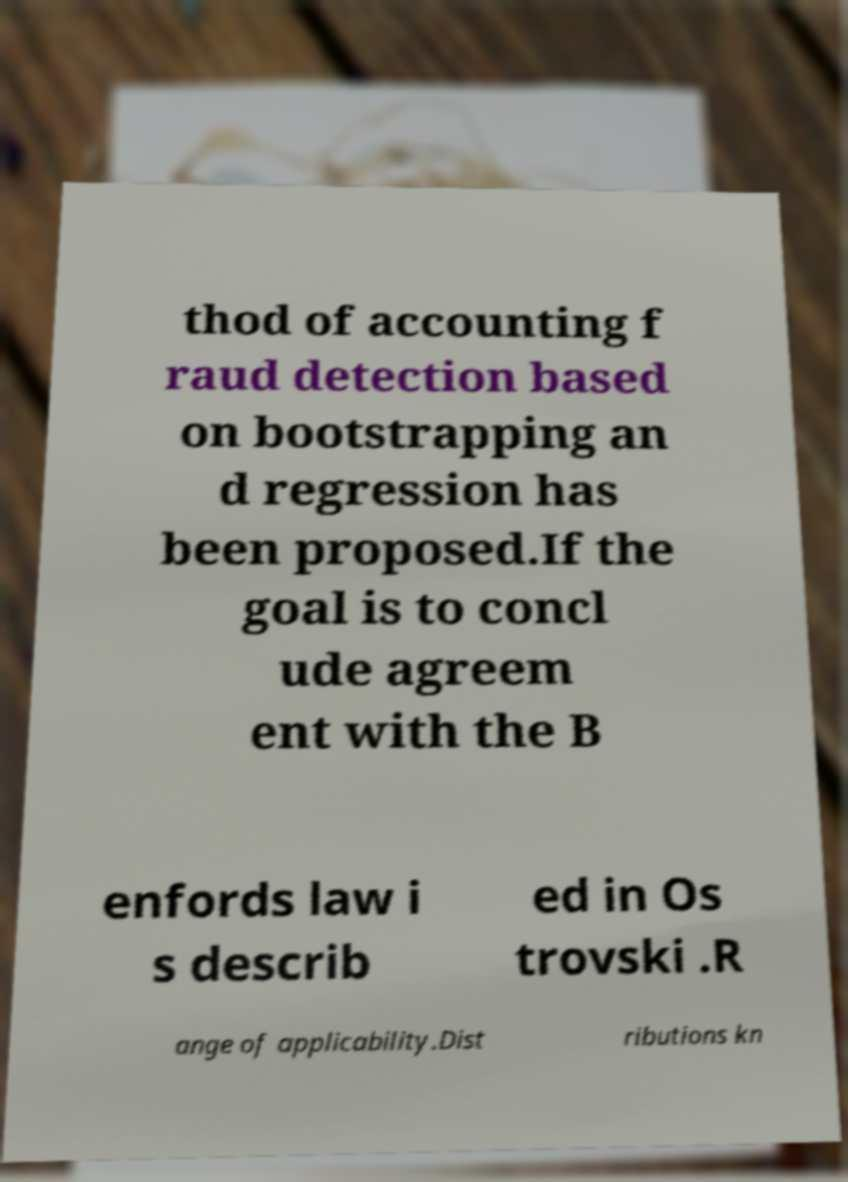I need the written content from this picture converted into text. Can you do that? thod of accounting f raud detection based on bootstrapping an d regression has been proposed.If the goal is to concl ude agreem ent with the B enfords law i s describ ed in Os trovski .R ange of applicability.Dist ributions kn 